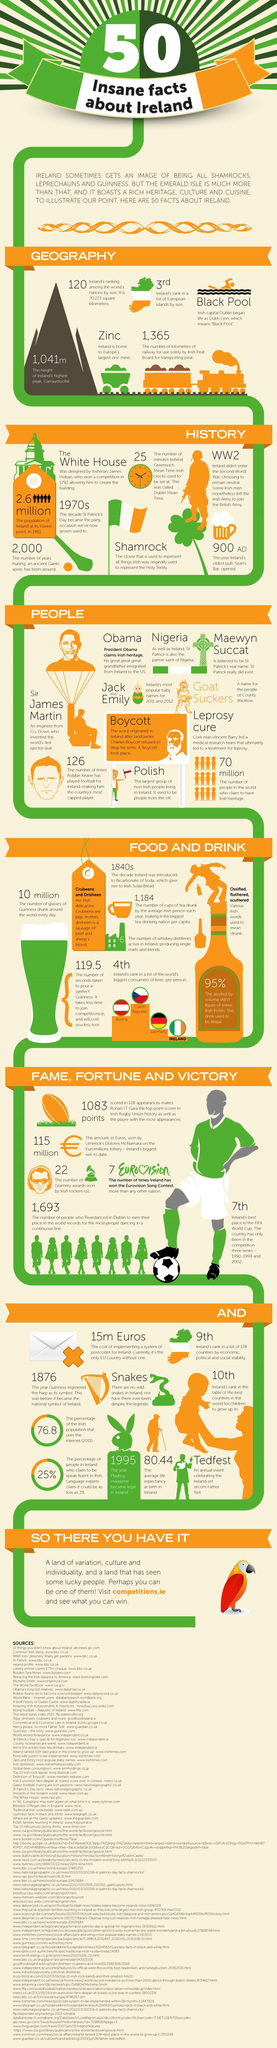List a handful of essential elements in this visual. The oldest pub in Ireland, which opened in 900 AD, is a historical landmark that has been serving the community for centuries. The total number of Grammy awards won by the Irish rock band U2 is 22. Germany is the third-largest consumer of beer in the world. According to the ranking of land size among other nations, Ireland holds the 120th position. Dublin is the capital of Ireland. 